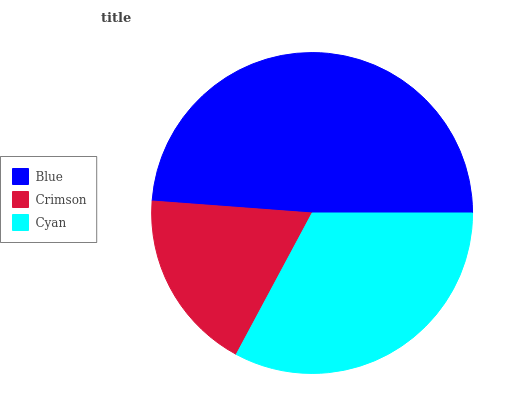Is Crimson the minimum?
Answer yes or no. Yes. Is Blue the maximum?
Answer yes or no. Yes. Is Cyan the minimum?
Answer yes or no. No. Is Cyan the maximum?
Answer yes or no. No. Is Cyan greater than Crimson?
Answer yes or no. Yes. Is Crimson less than Cyan?
Answer yes or no. Yes. Is Crimson greater than Cyan?
Answer yes or no. No. Is Cyan less than Crimson?
Answer yes or no. No. Is Cyan the high median?
Answer yes or no. Yes. Is Cyan the low median?
Answer yes or no. Yes. Is Blue the high median?
Answer yes or no. No. Is Crimson the low median?
Answer yes or no. No. 